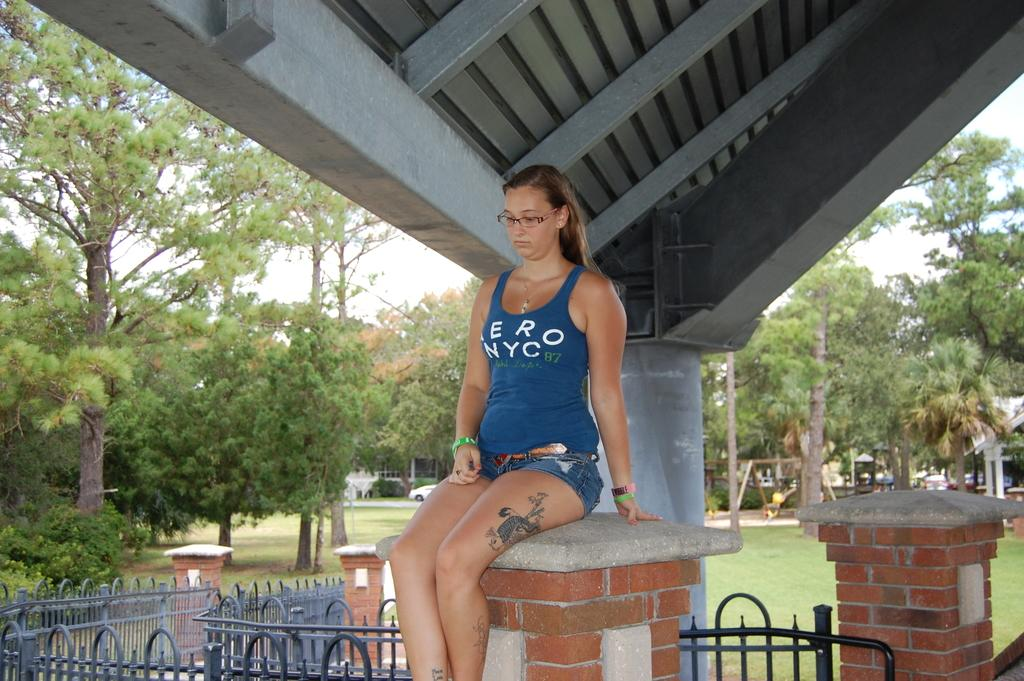What is the woman in the image doing? The woman is sitting on a wall in the image. What is the woman wearing on her upper body? A: The woman is wearing a blue top. What type of roof can be seen in the image? There is an iron roof visible in the image. What can be seen on the left side of the image? There are trees on the left side of the image. What type of mass can be seen in the wilderness in the image? There is no wilderness or mass present in the image; it features a woman sitting on a wall with an iron roof and trees on the left side. 